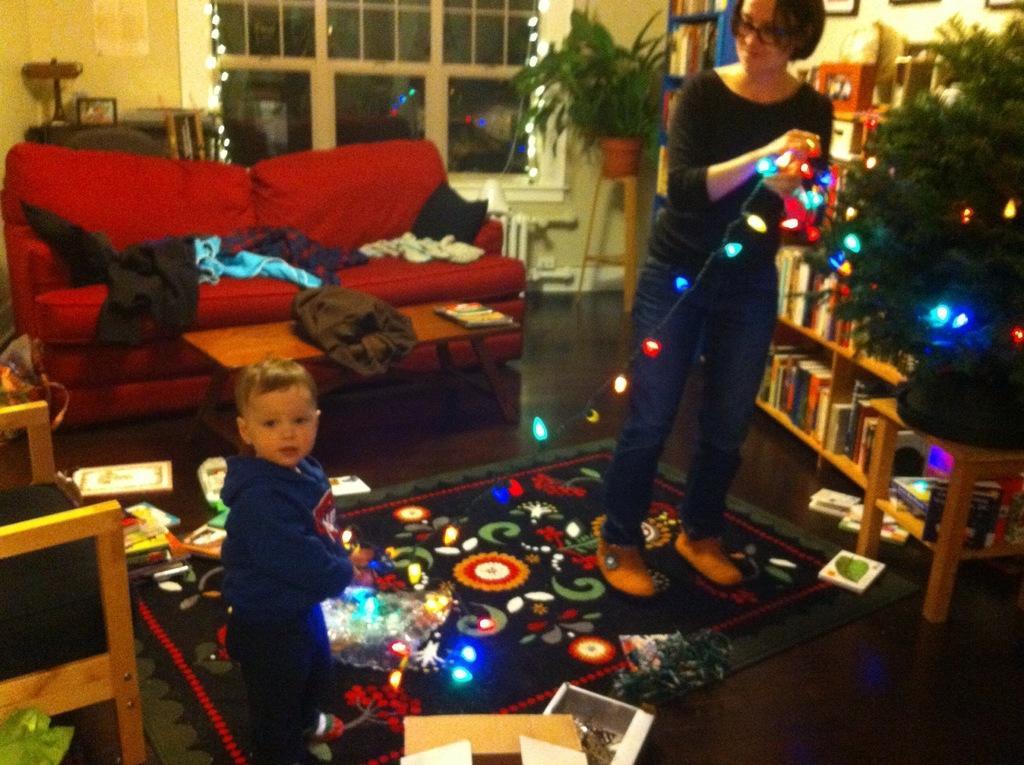In one or two sentences, can you explain what this image depicts? In this image I can see a woman and a child holding a lights. The woman is standing in front of the Christmas tree. At the back side I can see couch and a table. On the floor there are books. We can see window and a flower pot. On the right side there is a book rack. 